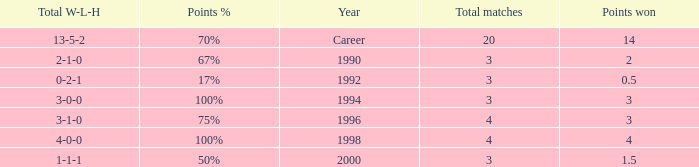Can you tell me the lowest Points won that has the Total matches of 4, and the Total W-L-H of 4-0-0? 4.0. 